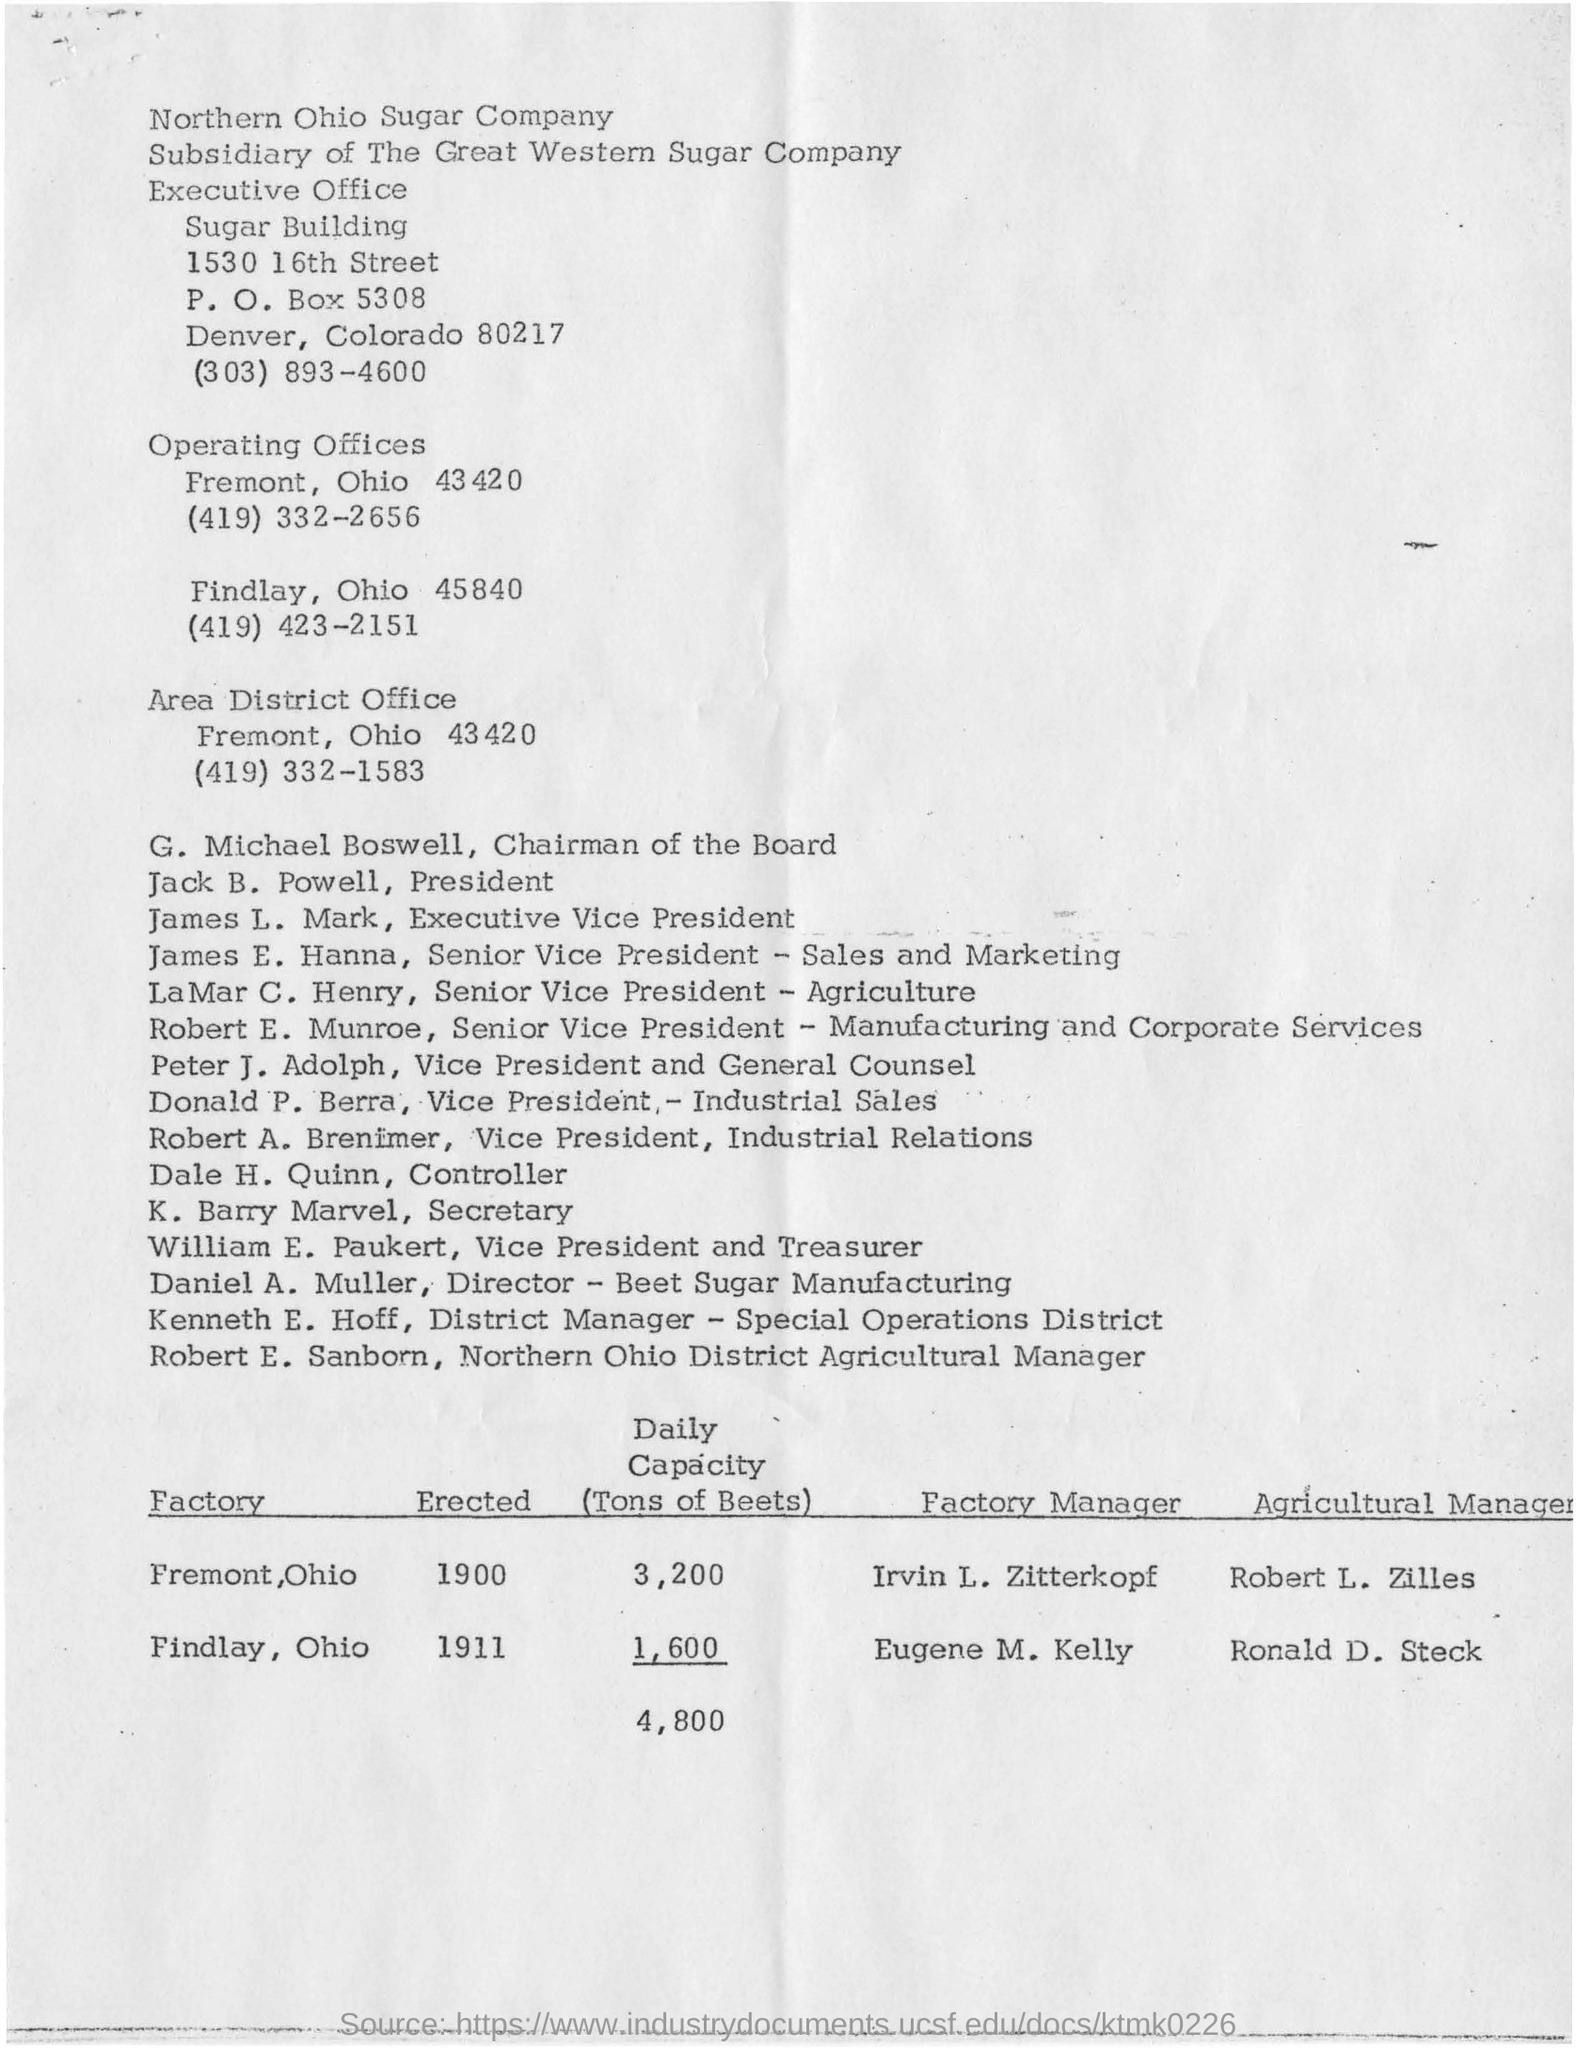What is the post box number for the location of 1530 16th street sugar building?
Keep it short and to the point. 5308. What is the contact number for the executive sugar building?
Ensure brevity in your answer.  (303) 893-4600. What is the location of operating offices?
Ensure brevity in your answer.  Fremont, ohio 43420. What is the contact number for the area district office?
Give a very brief answer. (419) 332-1583. Who is designated as the controller?
Make the answer very short. Dale h. quinn,. Who is the designated as the chairman of the board?
Keep it short and to the point. G. michael boswell. What is the total daily capacity tons of beets from both fremont and findlay factories?
Your response must be concise. 4,800. 